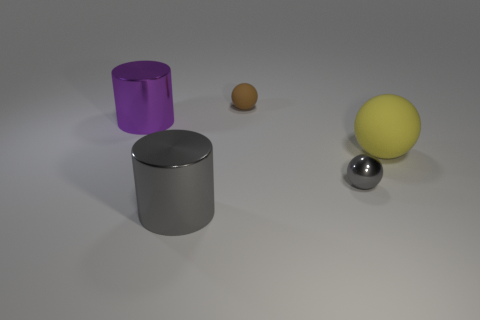Subtract all tiny balls. How many balls are left? 1 Add 3 purple objects. How many objects exist? 8 Subtract all gray balls. How many balls are left? 2 Subtract all cylinders. How many objects are left? 3 Subtract 2 spheres. How many spheres are left? 1 Subtract all cyan cylinders. Subtract all red cubes. How many cylinders are left? 2 Subtract all blue blocks. How many gray spheres are left? 1 Subtract all big yellow objects. Subtract all purple cylinders. How many objects are left? 3 Add 5 metallic things. How many metallic things are left? 8 Add 2 tiny cyan rubber objects. How many tiny cyan rubber objects exist? 2 